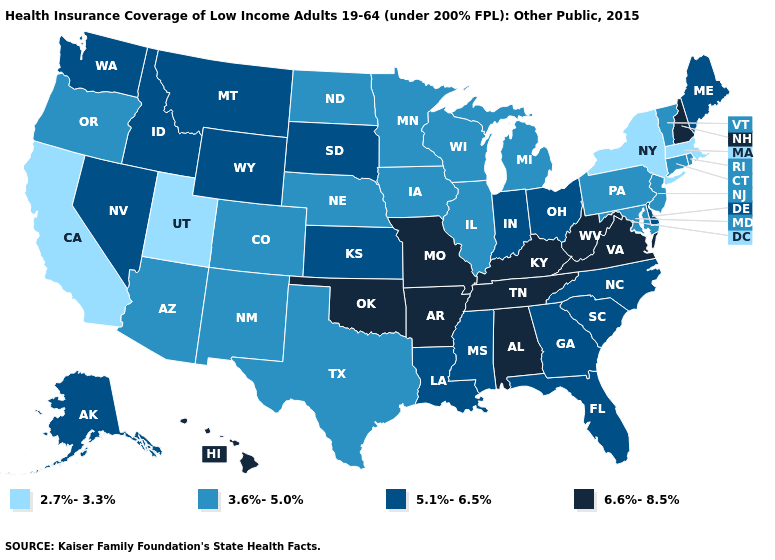Name the states that have a value in the range 3.6%-5.0%?
Answer briefly. Arizona, Colorado, Connecticut, Illinois, Iowa, Maryland, Michigan, Minnesota, Nebraska, New Jersey, New Mexico, North Dakota, Oregon, Pennsylvania, Rhode Island, Texas, Vermont, Wisconsin. What is the lowest value in the USA?
Short answer required. 2.7%-3.3%. What is the lowest value in the South?
Quick response, please. 3.6%-5.0%. What is the value of Wyoming?
Be succinct. 5.1%-6.5%. What is the highest value in the West ?
Write a very short answer. 6.6%-8.5%. Does Oklahoma have the highest value in the South?
Give a very brief answer. Yes. What is the value of New Jersey?
Answer briefly. 3.6%-5.0%. What is the highest value in the USA?
Concise answer only. 6.6%-8.5%. What is the value of Florida?
Answer briefly. 5.1%-6.5%. Name the states that have a value in the range 2.7%-3.3%?
Concise answer only. California, Massachusetts, New York, Utah. Does West Virginia have the same value as Florida?
Give a very brief answer. No. What is the value of New York?
Concise answer only. 2.7%-3.3%. What is the highest value in the USA?
Keep it brief. 6.6%-8.5%. What is the value of Nebraska?
Keep it brief. 3.6%-5.0%. What is the value of Mississippi?
Keep it brief. 5.1%-6.5%. 